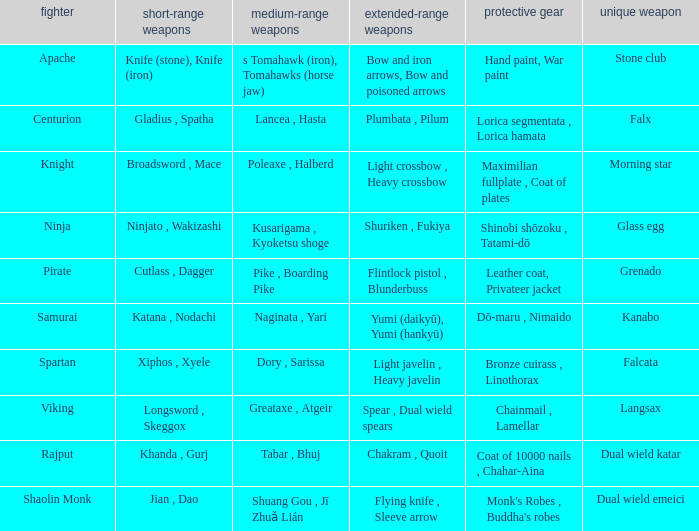Can you parse all the data within this table? {'header': ['fighter', 'short-range weapons', 'medium-range weapons', 'extended-range weapons', 'protective gear', 'unique weapon'], 'rows': [['Apache', 'Knife (stone), Knife (iron)', 's Tomahawk (iron), Tomahawks (horse jaw)', 'Bow and iron arrows, Bow and poisoned arrows', 'Hand paint, War paint', 'Stone club'], ['Centurion', 'Gladius , Spatha', 'Lancea , Hasta', 'Plumbata , Pilum', 'Lorica segmentata , Lorica hamata', 'Falx'], ['Knight', 'Broadsword , Mace', 'Poleaxe , Halberd', 'Light crossbow , Heavy crossbow', 'Maximilian fullplate , Coat of plates', 'Morning star'], ['Ninja', 'Ninjato , Wakizashi', 'Kusarigama , Kyoketsu shoge', 'Shuriken , Fukiya', 'Shinobi shōzoku , Tatami-dō', 'Glass egg'], ['Pirate', 'Cutlass , Dagger', 'Pike , Boarding Pike', 'Flintlock pistol , Blunderbuss', 'Leather coat, Privateer jacket', 'Grenado'], ['Samurai', 'Katana , Nodachi', 'Naginata , Yari', 'Yumi (daikyū), Yumi (hankyū)', 'Dō-maru , Nimaido', 'Kanabo'], ['Spartan', 'Xiphos , Xyele', 'Dory , Sarissa', 'Light javelin , Heavy javelin', 'Bronze cuirass , Linothorax', 'Falcata'], ['Viking', 'Longsword , Skeggox', 'Greataxe , Atgeir', 'Spear , Dual wield spears', 'Chainmail , Lamellar', 'Langsax'], ['Rajput', 'Khanda , Gurj', 'Tabar , Bhuj', 'Chakram , Quoit', 'Coat of 10000 nails , Chahar-Aina', 'Dual wield katar'], ['Shaolin Monk', 'Jian , Dao', 'Shuang Gou , Jī Zhuǎ Lián', 'Flying knife , Sleeve arrow', "Monk's Robes , Buddha's robes", 'Dual wield emeici']]} If the armor is bronze cuirass , linothorax, what are the close ranged weapons? Xiphos , Xyele. 